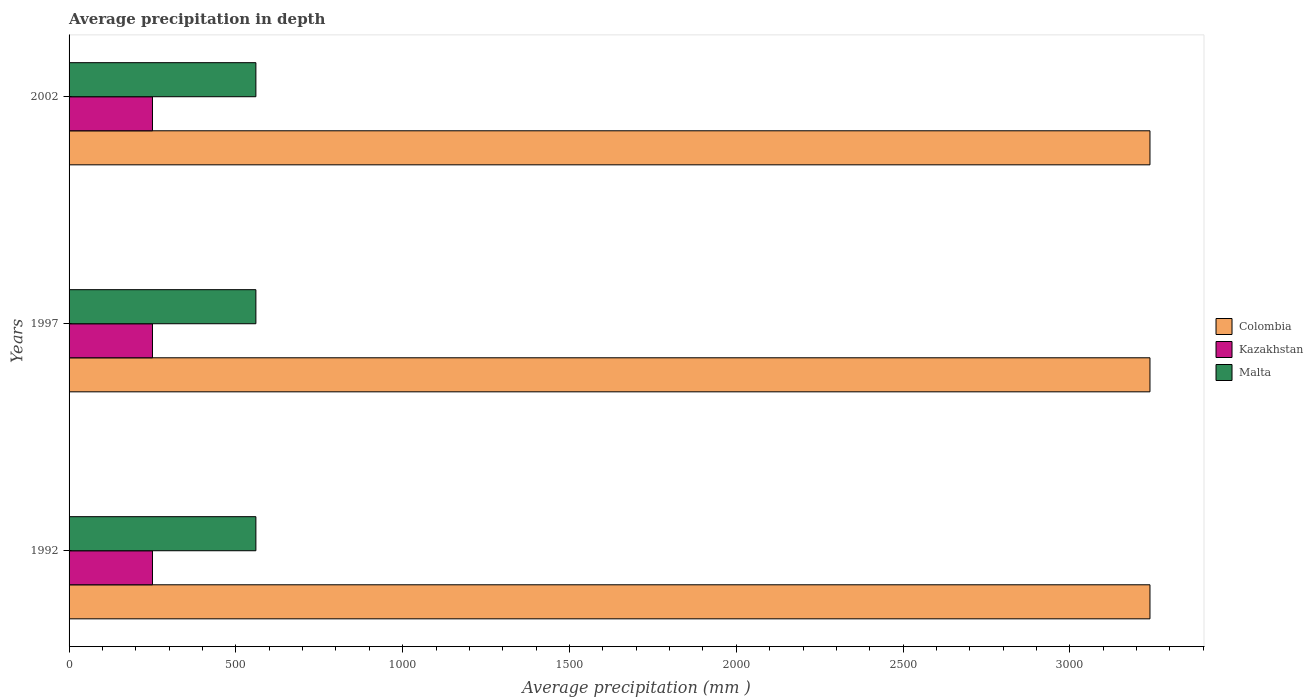How many different coloured bars are there?
Your answer should be very brief. 3. How many groups of bars are there?
Your answer should be very brief. 3. Are the number of bars on each tick of the Y-axis equal?
Make the answer very short. Yes. What is the average precipitation in Kazakhstan in 1997?
Provide a succinct answer. 250. Across all years, what is the maximum average precipitation in Malta?
Give a very brief answer. 560. Across all years, what is the minimum average precipitation in Colombia?
Offer a very short reply. 3240. In which year was the average precipitation in Colombia maximum?
Provide a short and direct response. 1992. What is the total average precipitation in Malta in the graph?
Your response must be concise. 1680. What is the difference between the average precipitation in Colombia in 1997 and the average precipitation in Malta in 2002?
Offer a terse response. 2680. What is the average average precipitation in Kazakhstan per year?
Your response must be concise. 250. In the year 1997, what is the difference between the average precipitation in Colombia and average precipitation in Malta?
Your response must be concise. 2680. In how many years, is the average precipitation in Colombia greater than 2400 mm?
Offer a very short reply. 3. Is the difference between the average precipitation in Colombia in 1997 and 2002 greater than the difference between the average precipitation in Malta in 1997 and 2002?
Make the answer very short. No. What is the difference between the highest and the lowest average precipitation in Colombia?
Offer a terse response. 0. In how many years, is the average precipitation in Colombia greater than the average average precipitation in Colombia taken over all years?
Provide a succinct answer. 0. Is the sum of the average precipitation in Colombia in 1997 and 2002 greater than the maximum average precipitation in Kazakhstan across all years?
Give a very brief answer. Yes. What does the 1st bar from the top in 2002 represents?
Provide a short and direct response. Malta. What does the 1st bar from the bottom in 1997 represents?
Your response must be concise. Colombia. Is it the case that in every year, the sum of the average precipitation in Colombia and average precipitation in Malta is greater than the average precipitation in Kazakhstan?
Offer a very short reply. Yes. How many bars are there?
Give a very brief answer. 9. Are the values on the major ticks of X-axis written in scientific E-notation?
Offer a very short reply. No. Does the graph contain any zero values?
Keep it short and to the point. No. Does the graph contain grids?
Your answer should be very brief. No. Where does the legend appear in the graph?
Offer a terse response. Center right. What is the title of the graph?
Your answer should be very brief. Average precipitation in depth. What is the label or title of the X-axis?
Your answer should be very brief. Average precipitation (mm ). What is the label or title of the Y-axis?
Your response must be concise. Years. What is the Average precipitation (mm ) in Colombia in 1992?
Make the answer very short. 3240. What is the Average precipitation (mm ) of Kazakhstan in 1992?
Your answer should be very brief. 250. What is the Average precipitation (mm ) of Malta in 1992?
Offer a very short reply. 560. What is the Average precipitation (mm ) in Colombia in 1997?
Ensure brevity in your answer.  3240. What is the Average precipitation (mm ) of Kazakhstan in 1997?
Give a very brief answer. 250. What is the Average precipitation (mm ) in Malta in 1997?
Give a very brief answer. 560. What is the Average precipitation (mm ) in Colombia in 2002?
Keep it short and to the point. 3240. What is the Average precipitation (mm ) in Kazakhstan in 2002?
Provide a succinct answer. 250. What is the Average precipitation (mm ) in Malta in 2002?
Ensure brevity in your answer.  560. Across all years, what is the maximum Average precipitation (mm ) in Colombia?
Provide a short and direct response. 3240. Across all years, what is the maximum Average precipitation (mm ) of Kazakhstan?
Ensure brevity in your answer.  250. Across all years, what is the maximum Average precipitation (mm ) of Malta?
Make the answer very short. 560. Across all years, what is the minimum Average precipitation (mm ) in Colombia?
Give a very brief answer. 3240. Across all years, what is the minimum Average precipitation (mm ) in Kazakhstan?
Your response must be concise. 250. Across all years, what is the minimum Average precipitation (mm ) in Malta?
Give a very brief answer. 560. What is the total Average precipitation (mm ) of Colombia in the graph?
Offer a terse response. 9720. What is the total Average precipitation (mm ) in Kazakhstan in the graph?
Your answer should be compact. 750. What is the total Average precipitation (mm ) of Malta in the graph?
Keep it short and to the point. 1680. What is the difference between the Average precipitation (mm ) of Colombia in 1992 and that in 1997?
Your response must be concise. 0. What is the difference between the Average precipitation (mm ) of Kazakhstan in 1992 and that in 1997?
Offer a terse response. 0. What is the difference between the Average precipitation (mm ) of Colombia in 1992 and that in 2002?
Give a very brief answer. 0. What is the difference between the Average precipitation (mm ) of Kazakhstan in 1992 and that in 2002?
Give a very brief answer. 0. What is the difference between the Average precipitation (mm ) in Colombia in 1997 and that in 2002?
Provide a succinct answer. 0. What is the difference between the Average precipitation (mm ) of Colombia in 1992 and the Average precipitation (mm ) of Kazakhstan in 1997?
Provide a short and direct response. 2990. What is the difference between the Average precipitation (mm ) in Colombia in 1992 and the Average precipitation (mm ) in Malta in 1997?
Your answer should be compact. 2680. What is the difference between the Average precipitation (mm ) in Kazakhstan in 1992 and the Average precipitation (mm ) in Malta in 1997?
Make the answer very short. -310. What is the difference between the Average precipitation (mm ) of Colombia in 1992 and the Average precipitation (mm ) of Kazakhstan in 2002?
Your response must be concise. 2990. What is the difference between the Average precipitation (mm ) in Colombia in 1992 and the Average precipitation (mm ) in Malta in 2002?
Offer a very short reply. 2680. What is the difference between the Average precipitation (mm ) in Kazakhstan in 1992 and the Average precipitation (mm ) in Malta in 2002?
Give a very brief answer. -310. What is the difference between the Average precipitation (mm ) in Colombia in 1997 and the Average precipitation (mm ) in Kazakhstan in 2002?
Provide a succinct answer. 2990. What is the difference between the Average precipitation (mm ) in Colombia in 1997 and the Average precipitation (mm ) in Malta in 2002?
Ensure brevity in your answer.  2680. What is the difference between the Average precipitation (mm ) of Kazakhstan in 1997 and the Average precipitation (mm ) of Malta in 2002?
Make the answer very short. -310. What is the average Average precipitation (mm ) in Colombia per year?
Make the answer very short. 3240. What is the average Average precipitation (mm ) of Kazakhstan per year?
Offer a terse response. 250. What is the average Average precipitation (mm ) in Malta per year?
Offer a very short reply. 560. In the year 1992, what is the difference between the Average precipitation (mm ) in Colombia and Average precipitation (mm ) in Kazakhstan?
Ensure brevity in your answer.  2990. In the year 1992, what is the difference between the Average precipitation (mm ) of Colombia and Average precipitation (mm ) of Malta?
Ensure brevity in your answer.  2680. In the year 1992, what is the difference between the Average precipitation (mm ) in Kazakhstan and Average precipitation (mm ) in Malta?
Your answer should be very brief. -310. In the year 1997, what is the difference between the Average precipitation (mm ) of Colombia and Average precipitation (mm ) of Kazakhstan?
Your response must be concise. 2990. In the year 1997, what is the difference between the Average precipitation (mm ) in Colombia and Average precipitation (mm ) in Malta?
Your response must be concise. 2680. In the year 1997, what is the difference between the Average precipitation (mm ) of Kazakhstan and Average precipitation (mm ) of Malta?
Ensure brevity in your answer.  -310. In the year 2002, what is the difference between the Average precipitation (mm ) of Colombia and Average precipitation (mm ) of Kazakhstan?
Keep it short and to the point. 2990. In the year 2002, what is the difference between the Average precipitation (mm ) in Colombia and Average precipitation (mm ) in Malta?
Provide a short and direct response. 2680. In the year 2002, what is the difference between the Average precipitation (mm ) in Kazakhstan and Average precipitation (mm ) in Malta?
Offer a terse response. -310. What is the ratio of the Average precipitation (mm ) in Colombia in 1992 to that in 1997?
Ensure brevity in your answer.  1. What is the ratio of the Average precipitation (mm ) in Kazakhstan in 1992 to that in 1997?
Give a very brief answer. 1. What is the ratio of the Average precipitation (mm ) in Malta in 1992 to that in 2002?
Provide a succinct answer. 1. What is the ratio of the Average precipitation (mm ) of Colombia in 1997 to that in 2002?
Your answer should be very brief. 1. What is the ratio of the Average precipitation (mm ) of Malta in 1997 to that in 2002?
Provide a short and direct response. 1. What is the difference between the highest and the second highest Average precipitation (mm ) of Colombia?
Keep it short and to the point. 0. What is the difference between the highest and the second highest Average precipitation (mm ) in Malta?
Offer a very short reply. 0. 